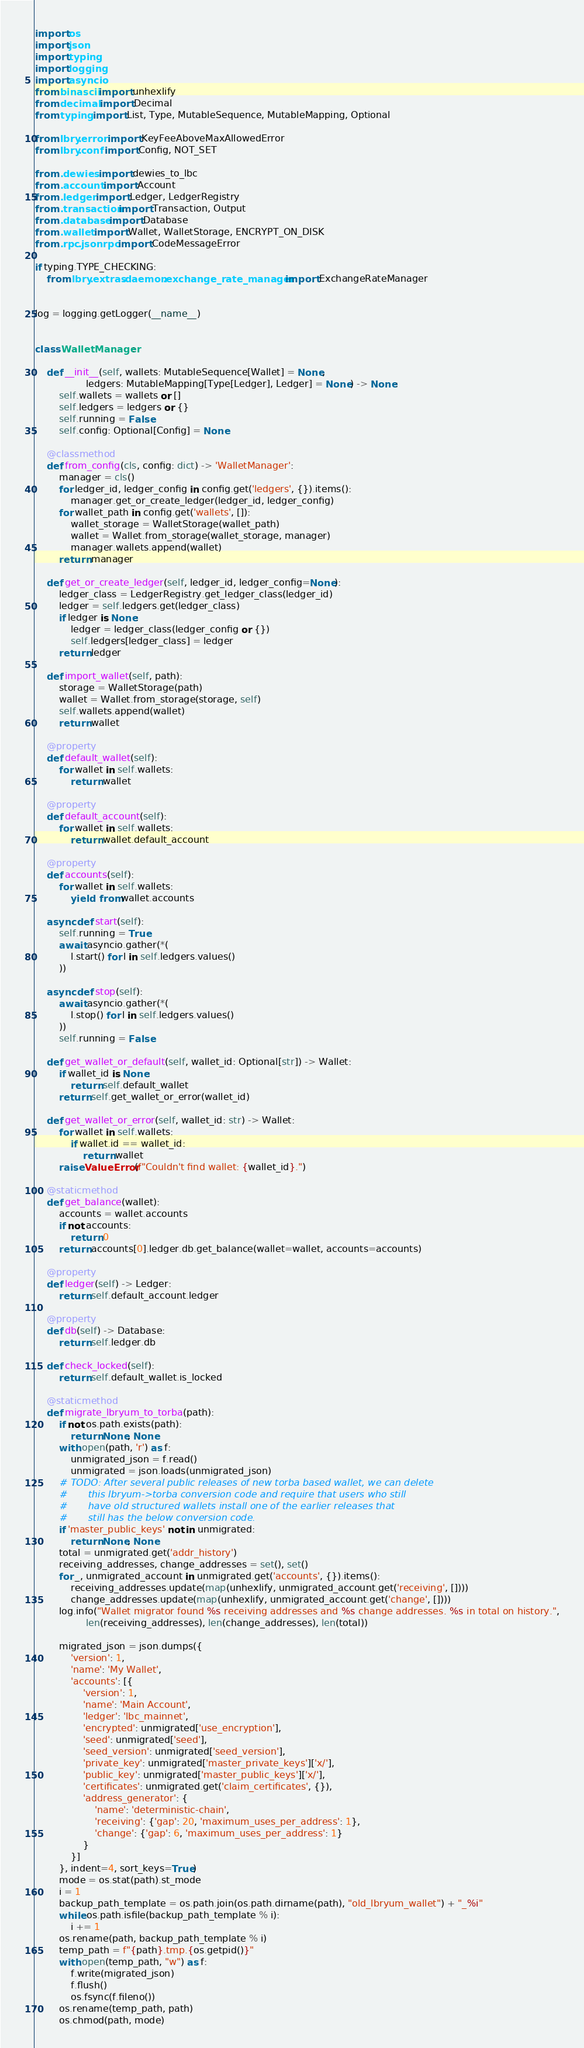Convert code to text. <code><loc_0><loc_0><loc_500><loc_500><_Python_>import os
import json
import typing
import logging
import asyncio
from binascii import unhexlify
from decimal import Decimal
from typing import List, Type, MutableSequence, MutableMapping, Optional

from lbry.error import KeyFeeAboveMaxAllowedError
from lbry.conf import Config, NOT_SET

from .dewies import dewies_to_lbc
from .account import Account
from .ledger import Ledger, LedgerRegistry
from .transaction import Transaction, Output
from .database import Database
from .wallet import Wallet, WalletStorage, ENCRYPT_ON_DISK
from .rpc.jsonrpc import CodeMessageError

if typing.TYPE_CHECKING:
    from lbry.extras.daemon.exchange_rate_manager import ExchangeRateManager


log = logging.getLogger(__name__)


class WalletManager:

    def __init__(self, wallets: MutableSequence[Wallet] = None,
                 ledgers: MutableMapping[Type[Ledger], Ledger] = None) -> None:
        self.wallets = wallets or []
        self.ledgers = ledgers or {}
        self.running = False
        self.config: Optional[Config] = None

    @classmethod
    def from_config(cls, config: dict) -> 'WalletManager':
        manager = cls()
        for ledger_id, ledger_config in config.get('ledgers', {}).items():
            manager.get_or_create_ledger(ledger_id, ledger_config)
        for wallet_path in config.get('wallets', []):
            wallet_storage = WalletStorage(wallet_path)
            wallet = Wallet.from_storage(wallet_storage, manager)
            manager.wallets.append(wallet)
        return manager

    def get_or_create_ledger(self, ledger_id, ledger_config=None):
        ledger_class = LedgerRegistry.get_ledger_class(ledger_id)
        ledger = self.ledgers.get(ledger_class)
        if ledger is None:
            ledger = ledger_class(ledger_config or {})
            self.ledgers[ledger_class] = ledger
        return ledger

    def import_wallet(self, path):
        storage = WalletStorage(path)
        wallet = Wallet.from_storage(storage, self)
        self.wallets.append(wallet)
        return wallet

    @property
    def default_wallet(self):
        for wallet in self.wallets:
            return wallet

    @property
    def default_account(self):
        for wallet in self.wallets:
            return wallet.default_account

    @property
    def accounts(self):
        for wallet in self.wallets:
            yield from wallet.accounts

    async def start(self):
        self.running = True
        await asyncio.gather(*(
            l.start() for l in self.ledgers.values()
        ))

    async def stop(self):
        await asyncio.gather(*(
            l.stop() for l in self.ledgers.values()
        ))
        self.running = False

    def get_wallet_or_default(self, wallet_id: Optional[str]) -> Wallet:
        if wallet_id is None:
            return self.default_wallet
        return self.get_wallet_or_error(wallet_id)

    def get_wallet_or_error(self, wallet_id: str) -> Wallet:
        for wallet in self.wallets:
            if wallet.id == wallet_id:
                return wallet
        raise ValueError(f"Couldn't find wallet: {wallet_id}.")

    @staticmethod
    def get_balance(wallet):
        accounts = wallet.accounts
        if not accounts:
            return 0
        return accounts[0].ledger.db.get_balance(wallet=wallet, accounts=accounts)

    @property
    def ledger(self) -> Ledger:
        return self.default_account.ledger

    @property
    def db(self) -> Database:
        return self.ledger.db

    def check_locked(self):
        return self.default_wallet.is_locked

    @staticmethod
    def migrate_lbryum_to_torba(path):
        if not os.path.exists(path):
            return None, None
        with open(path, 'r') as f:
            unmigrated_json = f.read()
            unmigrated = json.loads(unmigrated_json)
        # TODO: After several public releases of new torba based wallet, we can delete
        #       this lbryum->torba conversion code and require that users who still
        #       have old structured wallets install one of the earlier releases that
        #       still has the below conversion code.
        if 'master_public_keys' not in unmigrated:
            return None, None
        total = unmigrated.get('addr_history')
        receiving_addresses, change_addresses = set(), set()
        for _, unmigrated_account in unmigrated.get('accounts', {}).items():
            receiving_addresses.update(map(unhexlify, unmigrated_account.get('receiving', [])))
            change_addresses.update(map(unhexlify, unmigrated_account.get('change', [])))
        log.info("Wallet migrator found %s receiving addresses and %s change addresses. %s in total on history.",
                 len(receiving_addresses), len(change_addresses), len(total))

        migrated_json = json.dumps({
            'version': 1,
            'name': 'My Wallet',
            'accounts': [{
                'version': 1,
                'name': 'Main Account',
                'ledger': 'lbc_mainnet',
                'encrypted': unmigrated['use_encryption'],
                'seed': unmigrated['seed'],
                'seed_version': unmigrated['seed_version'],
                'private_key': unmigrated['master_private_keys']['x/'],
                'public_key': unmigrated['master_public_keys']['x/'],
                'certificates': unmigrated.get('claim_certificates', {}),
                'address_generator': {
                    'name': 'deterministic-chain',
                    'receiving': {'gap': 20, 'maximum_uses_per_address': 1},
                    'change': {'gap': 6, 'maximum_uses_per_address': 1}
                }
            }]
        }, indent=4, sort_keys=True)
        mode = os.stat(path).st_mode
        i = 1
        backup_path_template = os.path.join(os.path.dirname(path), "old_lbryum_wallet") + "_%i"
        while os.path.isfile(backup_path_template % i):
            i += 1
        os.rename(path, backup_path_template % i)
        temp_path = f"{path}.tmp.{os.getpid()}"
        with open(temp_path, "w") as f:
            f.write(migrated_json)
            f.flush()
            os.fsync(f.fileno())
        os.rename(temp_path, path)
        os.chmod(path, mode)</code> 